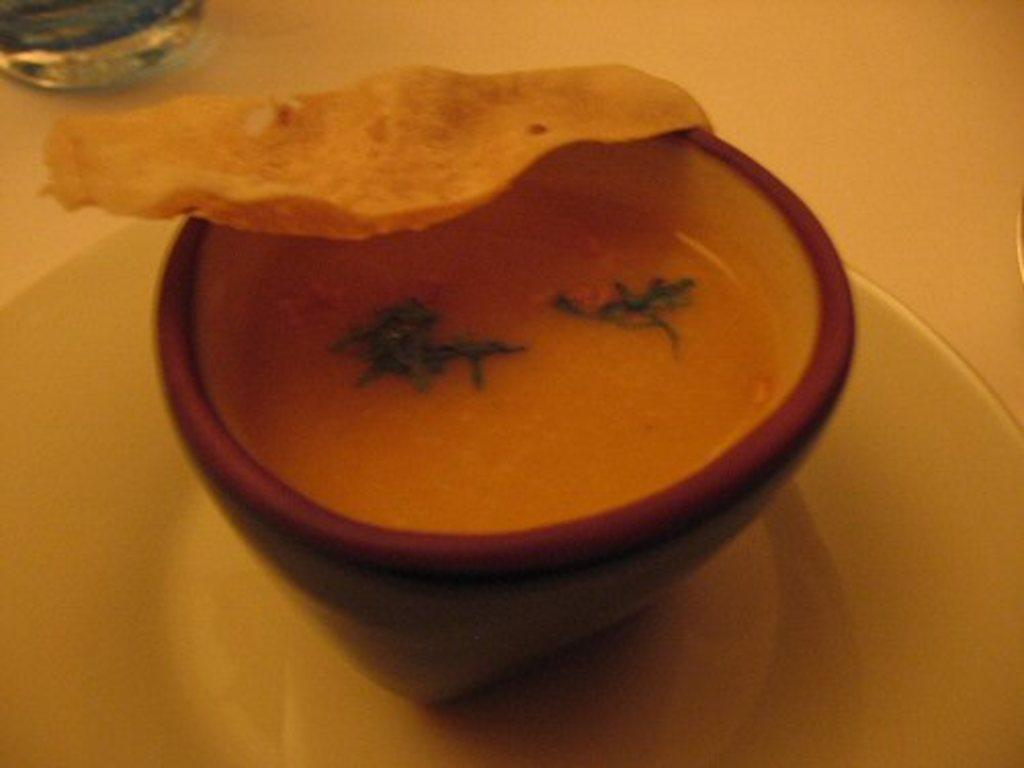What is on the plate in the image? There is a bowl on a plate in the image. What is inside the bowl? There is food in the bowl. Can you describe the object in the background? There is an object in the background on a surface, but its specific details are not clear from the provided facts. What type of pin is holding the food in place in the image? There is no pin present in the image, and the food is not being held in place by any visible means. 